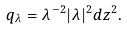Convert formula to latex. <formula><loc_0><loc_0><loc_500><loc_500>q _ { \lambda } = \lambda ^ { - 2 } | \lambda | ^ { 2 } d z ^ { 2 } .</formula> 